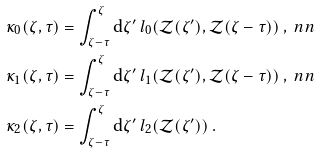Convert formula to latex. <formula><loc_0><loc_0><loc_500><loc_500>\kappa _ { 0 } ( \zeta , \tau ) & = \int ^ { \zeta } _ { \zeta - \tau } \mathrm d \zeta ^ { \prime } \, l _ { 0 } ( \mathcal { Z } ( \zeta ^ { \prime } ) , \mathcal { Z } ( \zeta - \tau ) ) \ , \ n n \\ \kappa _ { 1 } ( \zeta , \tau ) & = \int ^ { \zeta } _ { \zeta - \tau } \mathrm d \zeta ^ { \prime } \, l _ { 1 } ( \mathcal { Z } ( \zeta ^ { \prime } ) , \mathcal { Z } ( \zeta - \tau ) ) \ , \ n n \\ \kappa _ { 2 } ( \zeta , \tau ) & = \int ^ { \zeta } _ { \zeta - \tau } \mathrm d \zeta ^ { \prime } \, l _ { 2 } ( \mathcal { Z } ( \zeta ^ { \prime } ) ) \ .</formula> 